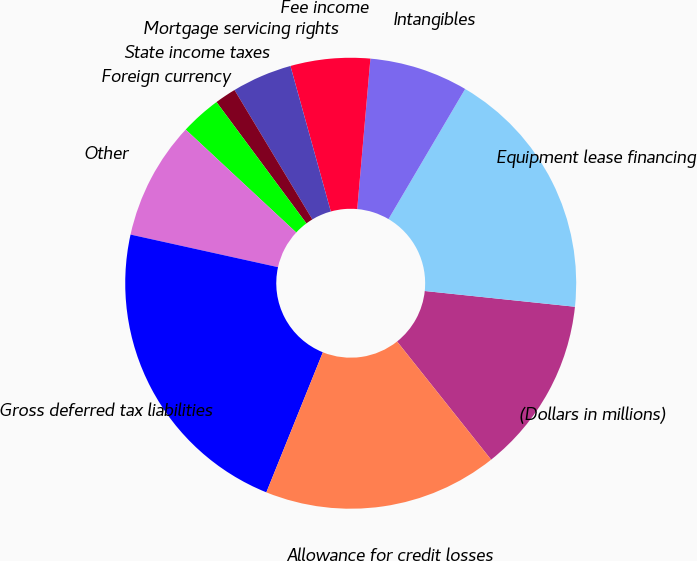<chart> <loc_0><loc_0><loc_500><loc_500><pie_chart><fcel>(Dollars in millions)<fcel>Equipment lease financing<fcel>Intangibles<fcel>Fee income<fcel>Mortgage servicing rights<fcel>State income taxes<fcel>Foreign currency<fcel>Other<fcel>Gross deferred tax liabilities<fcel>Allowance for credit losses<nl><fcel>12.64%<fcel>18.19%<fcel>7.08%<fcel>5.7%<fcel>4.31%<fcel>1.53%<fcel>2.92%<fcel>8.47%<fcel>22.36%<fcel>16.8%<nl></chart> 